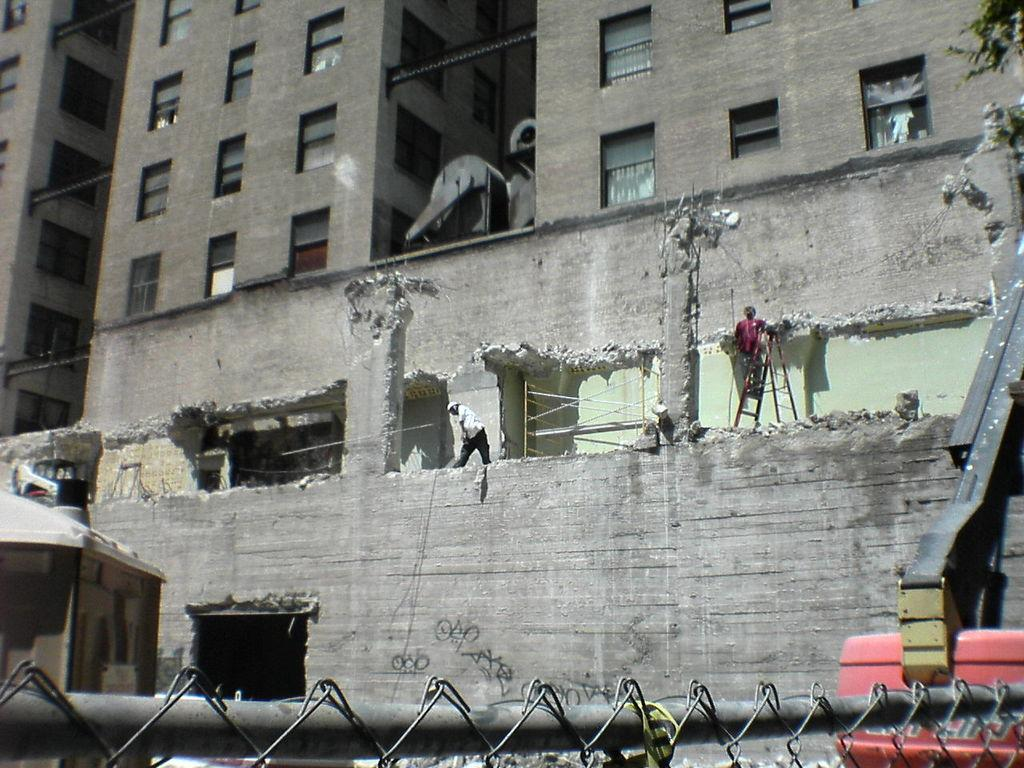What is the main subject of the image? The main subject of the image is persons in a building. What can be seen at the bottom of the image? There is a vehicle and fencing at the bottom of the image. What is happening in the background of the image? There is a building under excavation in the background of the image. What flavor of ice cream are the women enjoying in the image? There are no women or ice cream present in the image. 